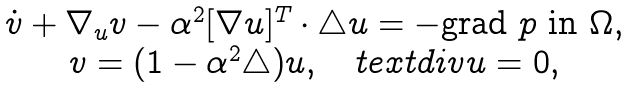<formula> <loc_0><loc_0><loc_500><loc_500>\begin{array} { c } \dot { v } + \nabla _ { u } v - \alpha ^ { 2 } [ \nabla u ] ^ { T } \cdot \triangle u = - \text {grad } p \text { in } \Omega , \\ v = ( 1 - \alpha ^ { 2 } \triangle ) u , \quad t e x t { d i v } u = 0 , \\ \end{array}</formula> 